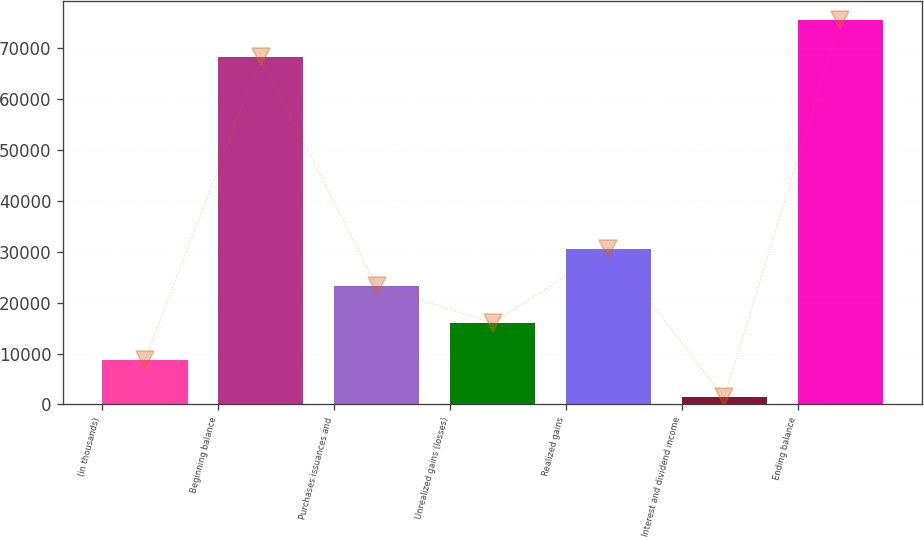<chart> <loc_0><loc_0><loc_500><loc_500><bar_chart><fcel>(in thousands)<fcel>Beginning balance<fcel>Purchases issuances and<fcel>Unrealized gains (losses)<fcel>Realized gains<fcel>Interest and dividend income<fcel>Ending balance<nl><fcel>8701.1<fcel>68102<fcel>23257.3<fcel>15979.2<fcel>30535.4<fcel>1423<fcel>75380.1<nl></chart> 